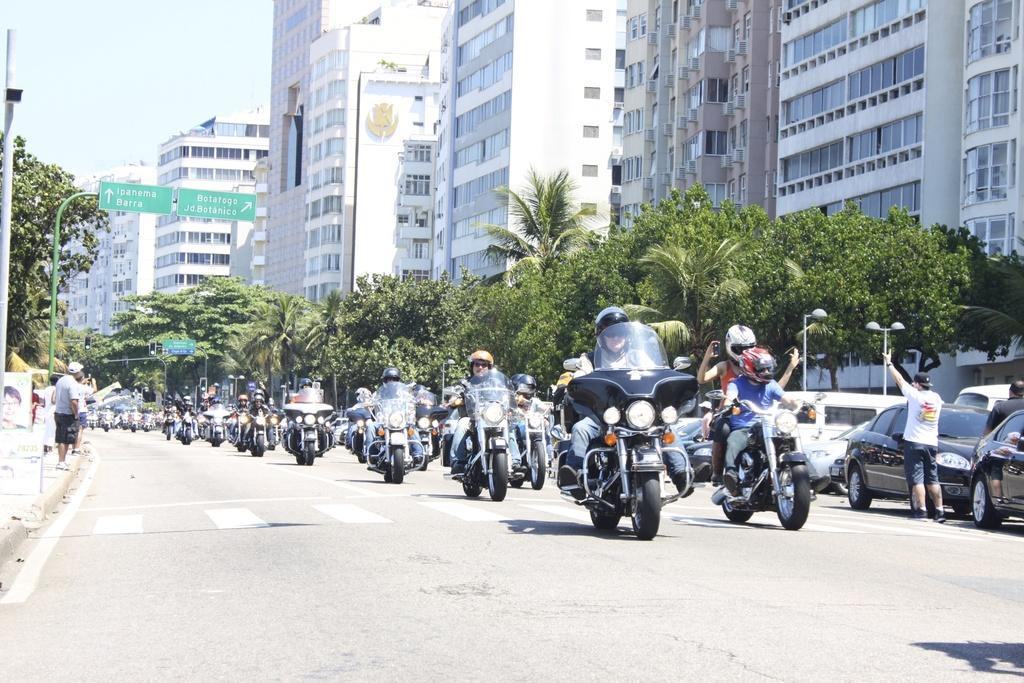In one or two sentences, can you explain what this image depicts? There is a building and so many people riding on bikes behind them there are few cars parked. 